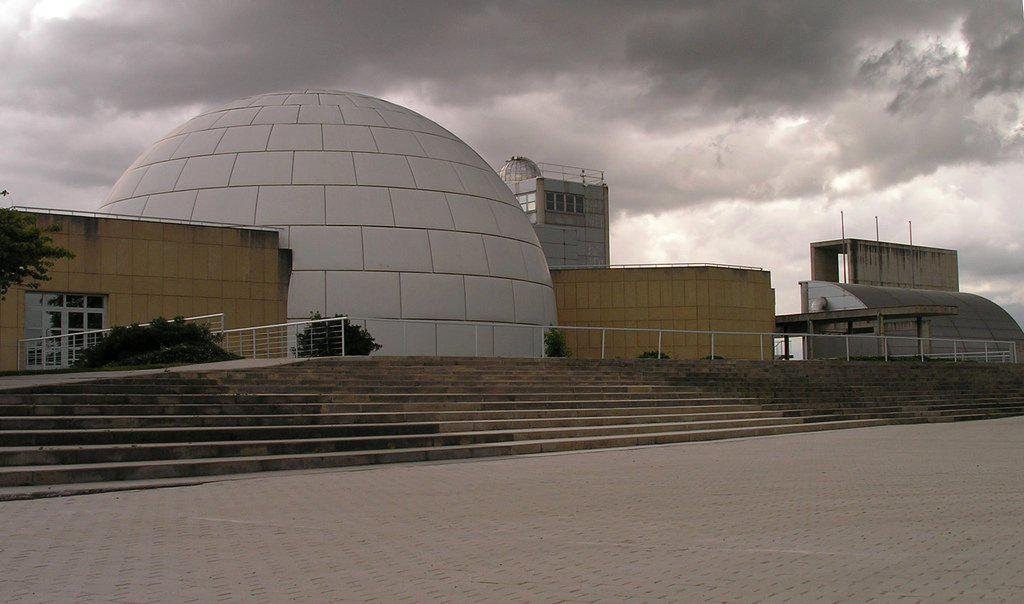What is located in the center of the image? There are stairs in the center of the image. What type of structures can be seen in the image? There are buildings in the image. What other elements are present in the image besides the stairs and buildings? There are plants, a railing, and a walkway at the bottom of the image. What is the condition of the sky in the image? The sky is cloudy at the top of the image. What type of verse can be heard recited by the bread in the image? There is no bread or verse present in the image; it features stairs, buildings, plants, a railing, and a walkway. How is the distribution of resources managed in the image? There is no reference to resources or their distribution in the image. 